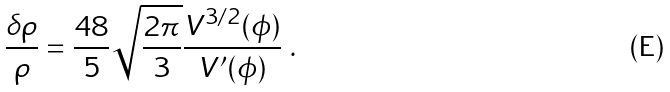<formula> <loc_0><loc_0><loc_500><loc_500>\frac { \delta \rho } { \rho } = \frac { 4 8 } { 5 } \sqrt { \frac { 2 \pi } { 3 } } \frac { V ^ { 3 / 2 } ( \phi ) } { V ^ { \prime } ( \phi ) } \ .</formula> 